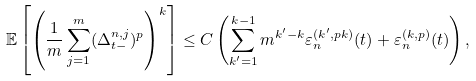<formula> <loc_0><loc_0><loc_500><loc_500>\mathbb { E } \left [ \left ( \frac { 1 } { m } \sum _ { j = 1 } ^ { m } ( \Delta ^ { n , j } _ { t - } ) ^ { p } \right ) ^ { k } \right ] \leq C \left ( \sum _ { k ^ { \prime } = 1 } ^ { k - 1 } m ^ { k ^ { \prime } - k } \varepsilon ^ { ( k ^ { \prime } , p k ) } _ { n } ( t ) + \varepsilon ^ { ( k , p ) } _ { n } ( t ) \right ) ,</formula> 